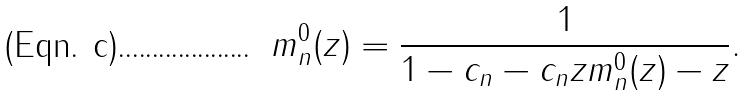Convert formula to latex. <formula><loc_0><loc_0><loc_500><loc_500>m _ { n } ^ { 0 } ( z ) = \frac { 1 } { 1 - c _ { n } - c _ { n } z m _ { n } ^ { 0 } ( z ) - z } .</formula> 